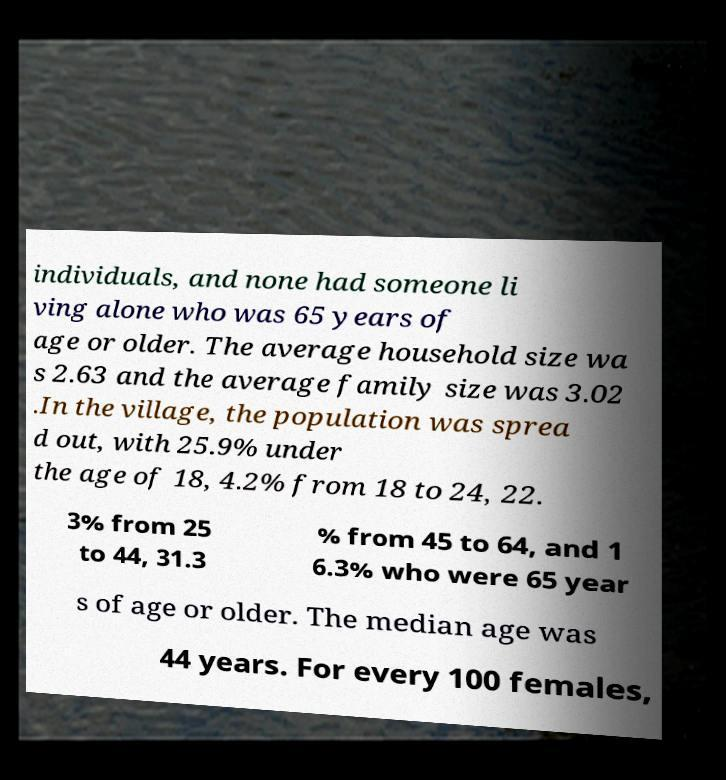Please identify and transcribe the text found in this image. individuals, and none had someone li ving alone who was 65 years of age or older. The average household size wa s 2.63 and the average family size was 3.02 .In the village, the population was sprea d out, with 25.9% under the age of 18, 4.2% from 18 to 24, 22. 3% from 25 to 44, 31.3 % from 45 to 64, and 1 6.3% who were 65 year s of age or older. The median age was 44 years. For every 100 females, 